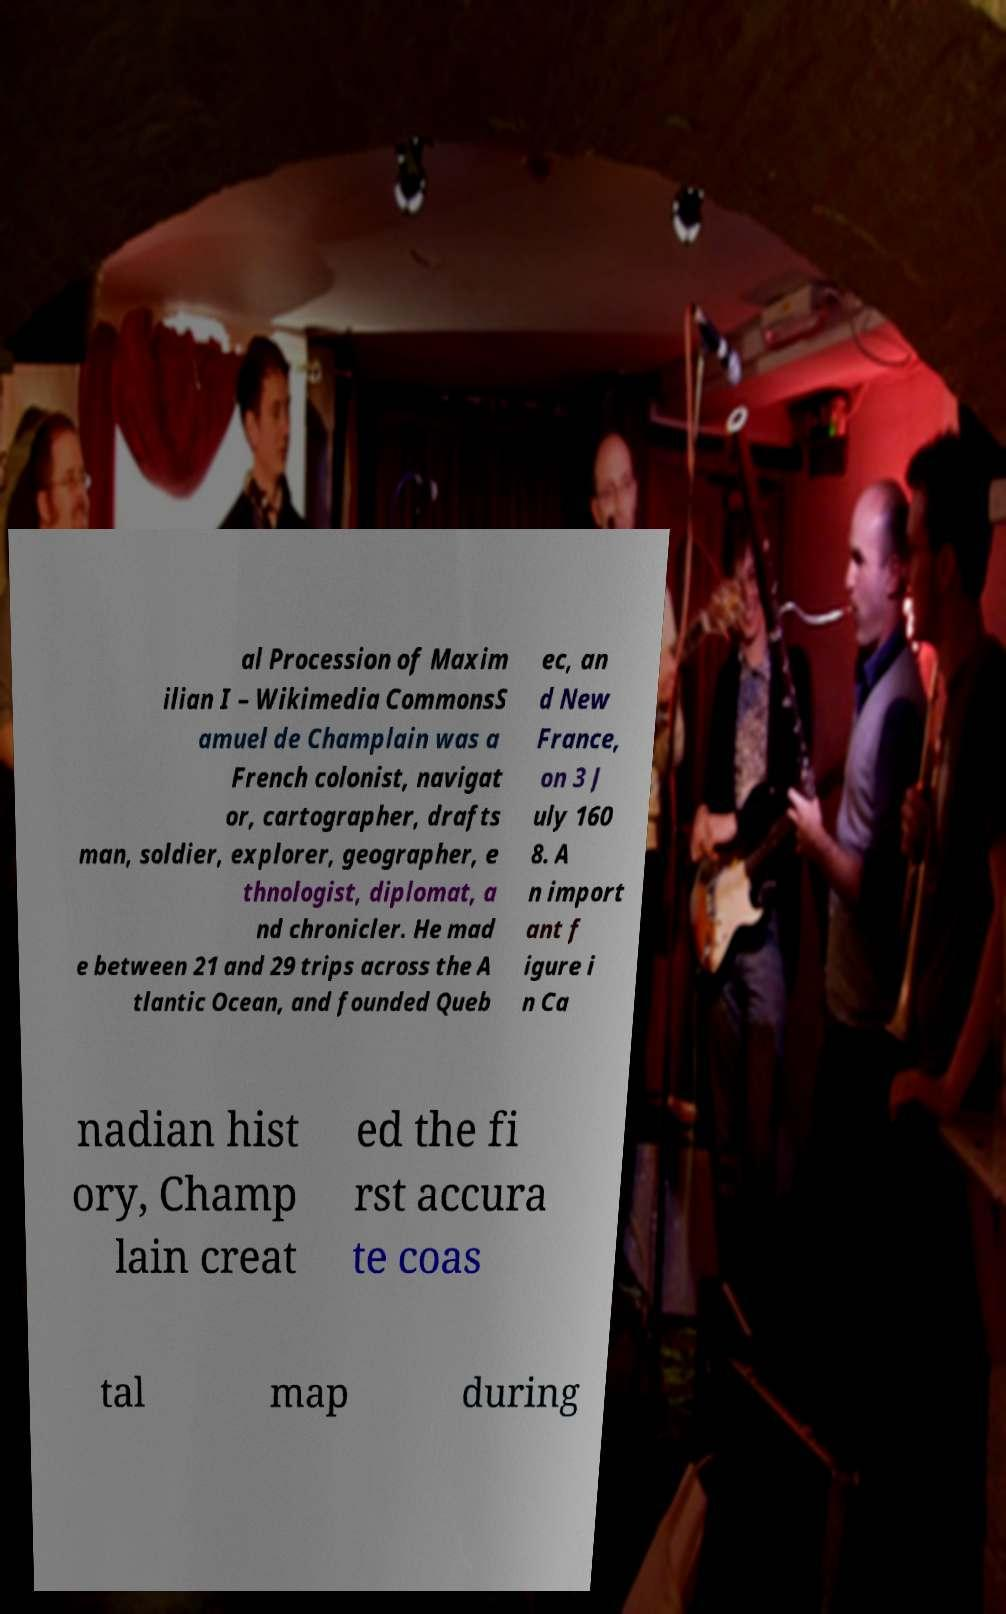Can you read and provide the text displayed in the image?This photo seems to have some interesting text. Can you extract and type it out for me? al Procession of Maxim ilian I – Wikimedia CommonsS amuel de Champlain was a French colonist, navigat or, cartographer, drafts man, soldier, explorer, geographer, e thnologist, diplomat, a nd chronicler. He mad e between 21 and 29 trips across the A tlantic Ocean, and founded Queb ec, an d New France, on 3 J uly 160 8. A n import ant f igure i n Ca nadian hist ory, Champ lain creat ed the fi rst accura te coas tal map during 